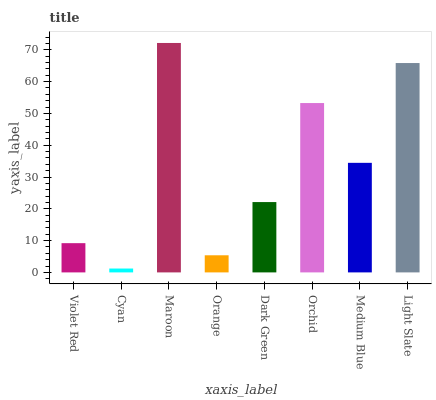Is Cyan the minimum?
Answer yes or no. Yes. Is Maroon the maximum?
Answer yes or no. Yes. Is Maroon the minimum?
Answer yes or no. No. Is Cyan the maximum?
Answer yes or no. No. Is Maroon greater than Cyan?
Answer yes or no. Yes. Is Cyan less than Maroon?
Answer yes or no. Yes. Is Cyan greater than Maroon?
Answer yes or no. No. Is Maroon less than Cyan?
Answer yes or no. No. Is Medium Blue the high median?
Answer yes or no. Yes. Is Dark Green the low median?
Answer yes or no. Yes. Is Violet Red the high median?
Answer yes or no. No. Is Medium Blue the low median?
Answer yes or no. No. 